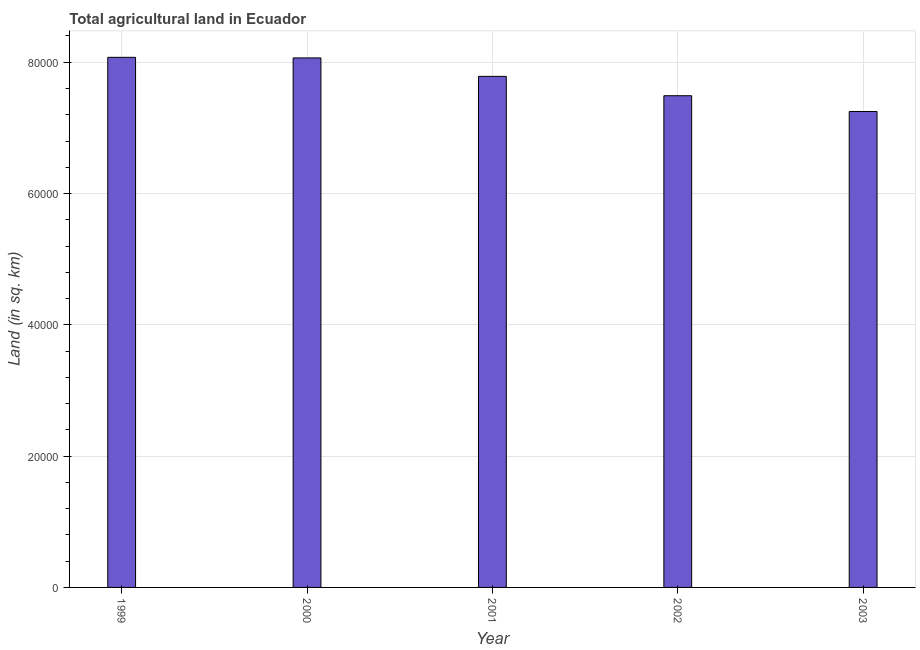Does the graph contain any zero values?
Your answer should be very brief. No. What is the title of the graph?
Your response must be concise. Total agricultural land in Ecuador. What is the label or title of the X-axis?
Make the answer very short. Year. What is the label or title of the Y-axis?
Your answer should be compact. Land (in sq. km). What is the agricultural land in 2002?
Offer a very short reply. 7.49e+04. Across all years, what is the maximum agricultural land?
Keep it short and to the point. 8.08e+04. Across all years, what is the minimum agricultural land?
Offer a terse response. 7.25e+04. In which year was the agricultural land maximum?
Ensure brevity in your answer.  1999. What is the sum of the agricultural land?
Give a very brief answer. 3.87e+05. What is the difference between the agricultural land in 2000 and 2002?
Ensure brevity in your answer.  5760. What is the average agricultural land per year?
Keep it short and to the point. 7.73e+04. What is the median agricultural land?
Your answer should be compact. 7.78e+04. Is the agricultural land in 1999 less than that in 2001?
Give a very brief answer. No. What is the difference between the highest and the second highest agricultural land?
Offer a terse response. 90. Is the sum of the agricultural land in 1999 and 2002 greater than the maximum agricultural land across all years?
Give a very brief answer. Yes. What is the difference between the highest and the lowest agricultural land?
Offer a very short reply. 8250. In how many years, is the agricultural land greater than the average agricultural land taken over all years?
Provide a succinct answer. 3. How many bars are there?
Make the answer very short. 5. What is the difference between two consecutive major ticks on the Y-axis?
Ensure brevity in your answer.  2.00e+04. Are the values on the major ticks of Y-axis written in scientific E-notation?
Provide a short and direct response. No. What is the Land (in sq. km) of 1999?
Provide a short and direct response. 8.08e+04. What is the Land (in sq. km) in 2000?
Provide a succinct answer. 8.07e+04. What is the Land (in sq. km) of 2001?
Your response must be concise. 7.78e+04. What is the Land (in sq. km) in 2002?
Provide a succinct answer. 7.49e+04. What is the Land (in sq. km) of 2003?
Offer a terse response. 7.25e+04. What is the difference between the Land (in sq. km) in 1999 and 2000?
Give a very brief answer. 90. What is the difference between the Land (in sq. km) in 1999 and 2001?
Your answer should be very brief. 2900. What is the difference between the Land (in sq. km) in 1999 and 2002?
Give a very brief answer. 5850. What is the difference between the Land (in sq. km) in 1999 and 2003?
Offer a very short reply. 8250. What is the difference between the Land (in sq. km) in 2000 and 2001?
Ensure brevity in your answer.  2810. What is the difference between the Land (in sq. km) in 2000 and 2002?
Offer a terse response. 5760. What is the difference between the Land (in sq. km) in 2000 and 2003?
Your response must be concise. 8160. What is the difference between the Land (in sq. km) in 2001 and 2002?
Offer a terse response. 2950. What is the difference between the Land (in sq. km) in 2001 and 2003?
Your response must be concise. 5350. What is the difference between the Land (in sq. km) in 2002 and 2003?
Make the answer very short. 2400. What is the ratio of the Land (in sq. km) in 1999 to that in 2002?
Your response must be concise. 1.08. What is the ratio of the Land (in sq. km) in 1999 to that in 2003?
Your answer should be compact. 1.11. What is the ratio of the Land (in sq. km) in 2000 to that in 2001?
Your answer should be compact. 1.04. What is the ratio of the Land (in sq. km) in 2000 to that in 2002?
Your answer should be compact. 1.08. What is the ratio of the Land (in sq. km) in 2000 to that in 2003?
Offer a terse response. 1.11. What is the ratio of the Land (in sq. km) in 2001 to that in 2002?
Keep it short and to the point. 1.04. What is the ratio of the Land (in sq. km) in 2001 to that in 2003?
Your answer should be compact. 1.07. What is the ratio of the Land (in sq. km) in 2002 to that in 2003?
Your answer should be compact. 1.03. 